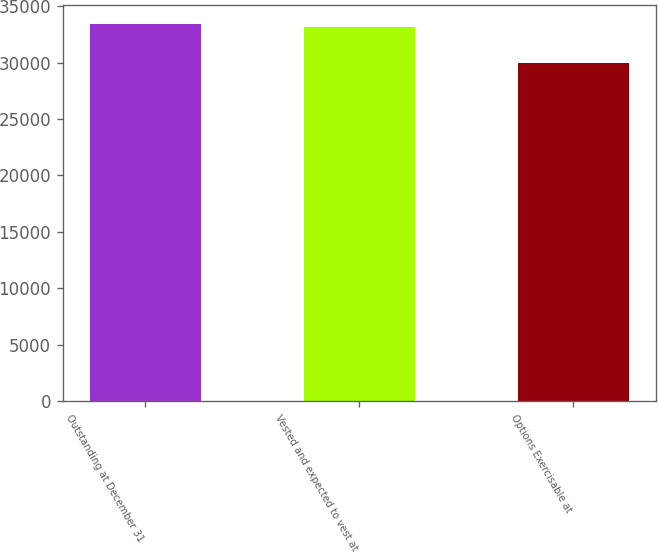Convert chart. <chart><loc_0><loc_0><loc_500><loc_500><bar_chart><fcel>Outstanding at December 31<fcel>Vested and expected to vest at<fcel>Options Exercisable at<nl><fcel>33451.2<fcel>33130<fcel>29970<nl></chart> 